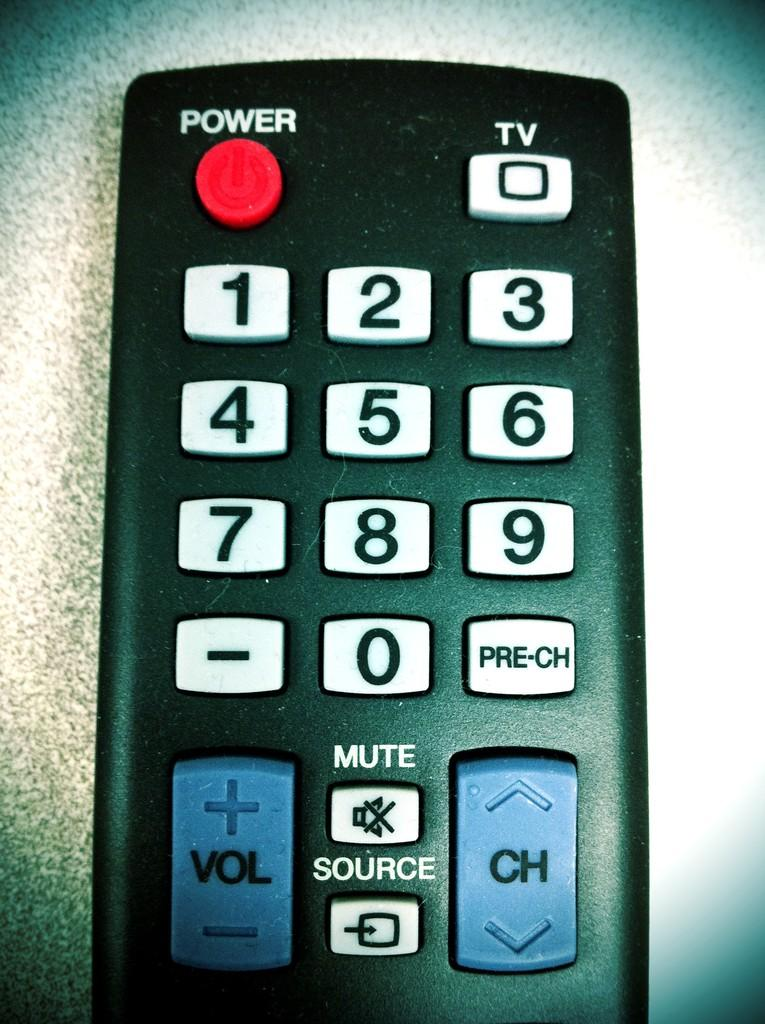<image>
Render a clear and concise summary of the photo. A remote with a red Power button, a Mute button, and a blue Volume and Channel button. 